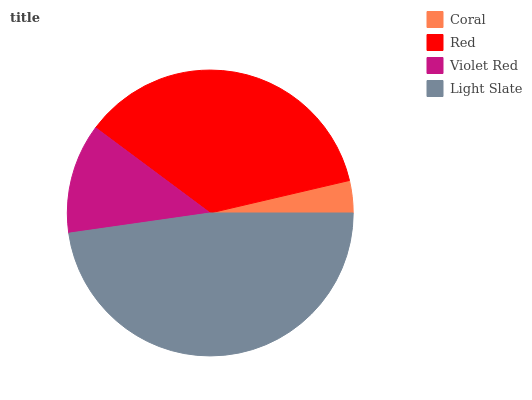Is Coral the minimum?
Answer yes or no. Yes. Is Light Slate the maximum?
Answer yes or no. Yes. Is Red the minimum?
Answer yes or no. No. Is Red the maximum?
Answer yes or no. No. Is Red greater than Coral?
Answer yes or no. Yes. Is Coral less than Red?
Answer yes or no. Yes. Is Coral greater than Red?
Answer yes or no. No. Is Red less than Coral?
Answer yes or no. No. Is Red the high median?
Answer yes or no. Yes. Is Violet Red the low median?
Answer yes or no. Yes. Is Light Slate the high median?
Answer yes or no. No. Is Light Slate the low median?
Answer yes or no. No. 